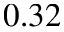Convert formula to latex. <formula><loc_0><loc_0><loc_500><loc_500>0 . 3 2</formula> 